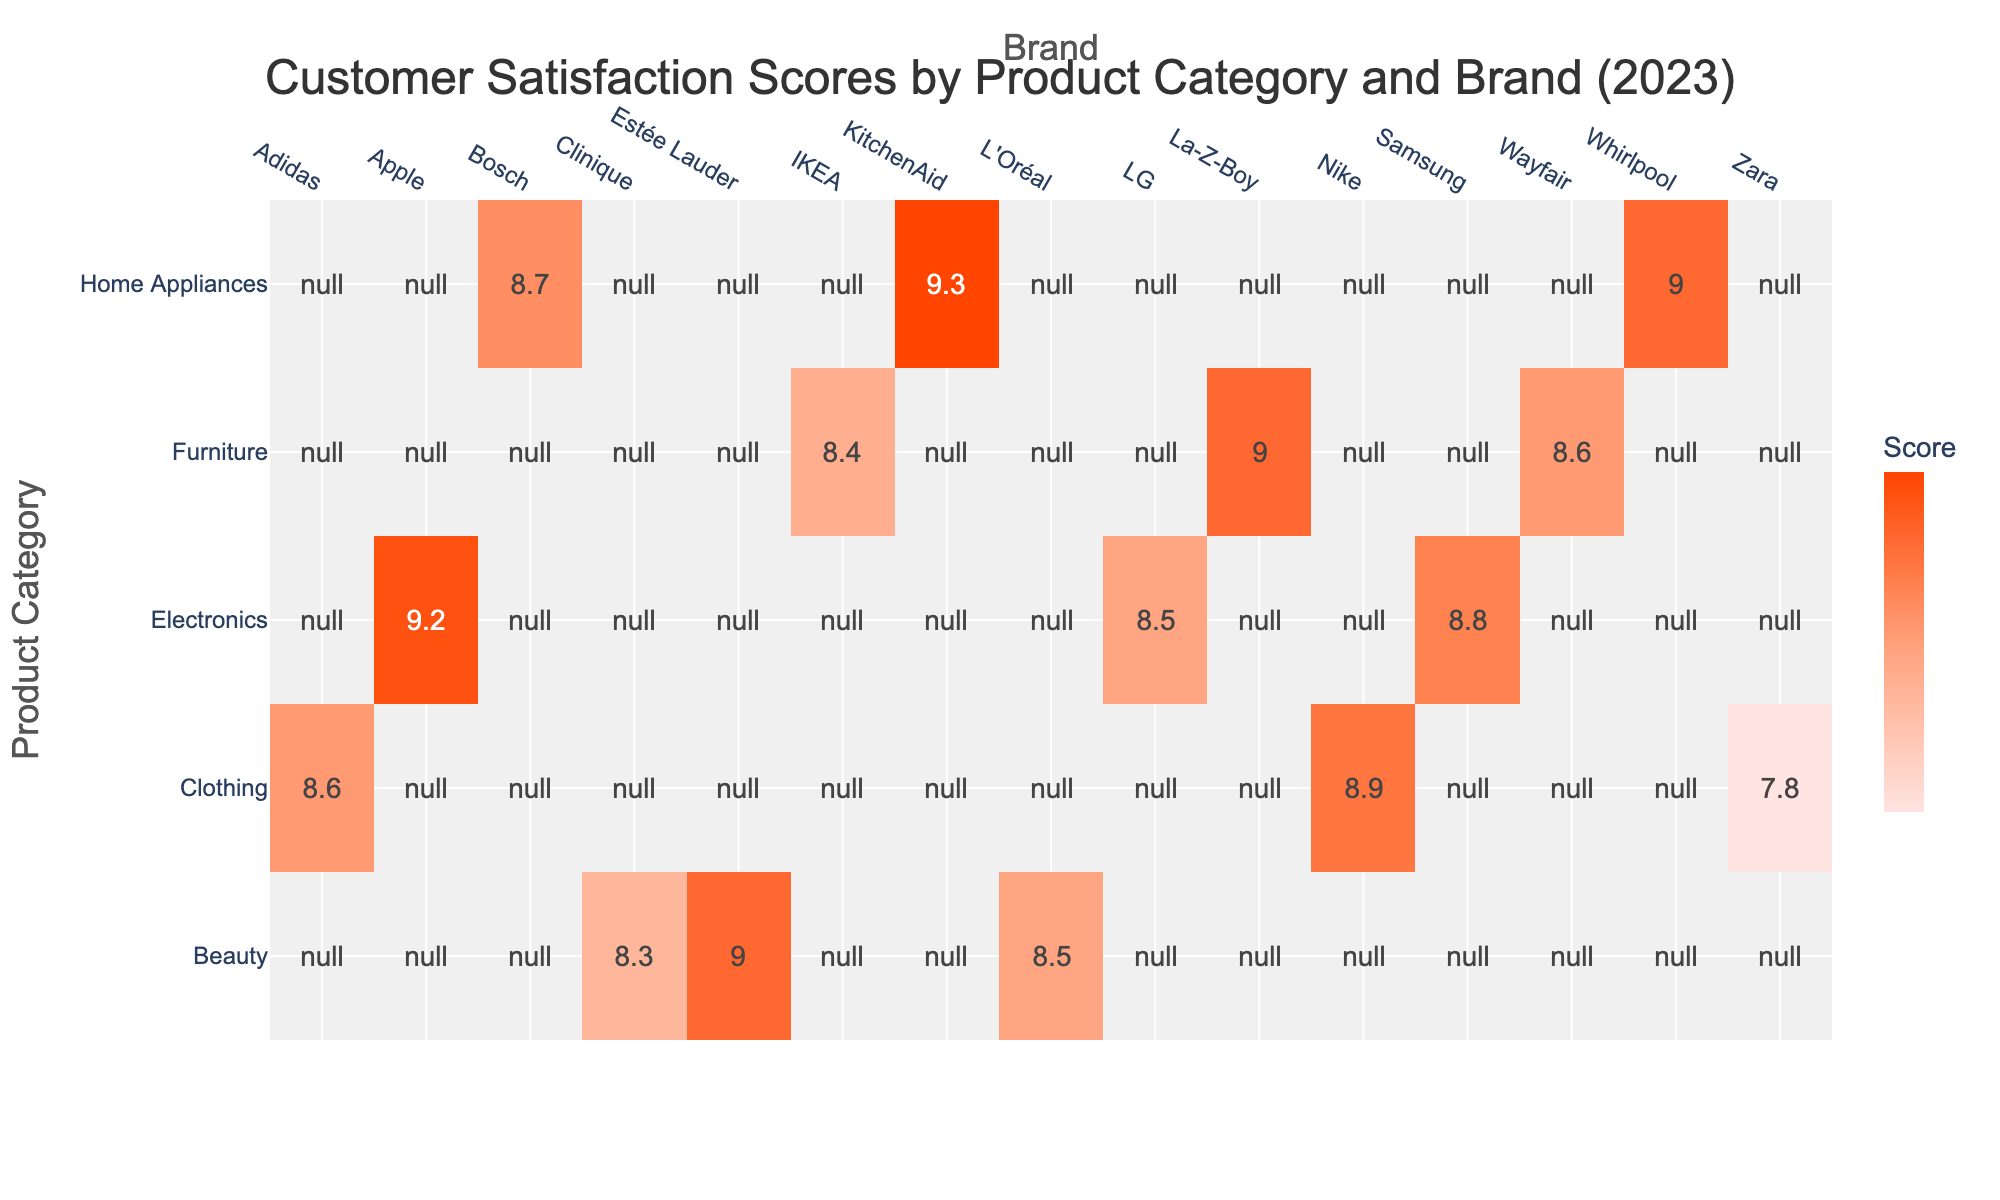What is the Customer Satisfaction Score for KitchenAid? Looking at the table, the score for the KitchenAid brand under the Home Appliances category is directly stated as 9.3.
Answer: 9.3 Which brand in the Electronics category has the lowest Customer Satisfaction Score? Within the Electronics category, we compare the scores: Apple (9.2), Samsung (8.8), and LG (8.5). The lowest score is from LG, which is 8.5.
Answer: LG What is the average Customer Satisfaction Score for the Furniture category? To find the average, we need the scores for IKEA (8.4), La-Z-Boy (9.0), and Wayfair (8.6). The sum is 8.4 + 9.0 + 8.6 = 26. The average then is calculated as 26/3 = 8.67.
Answer: 8.67 Is L'Oréal's Customer Satisfaction Score higher than that of Nike? The score for L'Oréal in the Beauty category is 8.5, while Nike's score in the Clothing category is 8.9. Since 8.5 is less than 8.9, the answer is no.
Answer: No Which product category has the highest Customer Satisfaction Score, and what is that score? We compare the highest scores across categories: Electronics has a maximum of 9.2 (Apple), Home Appliances has 9.3 (KitchenAid), Furniture has 9.0 (La-Z-Boy), Clothing has 8.9 (Nike), and Beauty has 9.0 (Estée Lauder). The highest is from the Home Appliances category with 9.3.
Answer: Home Appliances, 9.3 What is the total number of responses for the brands under the Clothing category? The Clothing category comprises Nike (1400), Adidas (1100), and Zara (650). Adding these gives 1400 + 1100 + 650 = 3150 responses in total.
Answer: 3150 Does the score for Samsung exceed the average of the scores in the Home Appliances category? The Home Appliances scores are Whirlpool (9.0), Bosch (8.7), and KitchenAid (9.3). The average is (9.0 + 8.7 + 9.3) / 3 = 9.0. Samsung’s score is 8.8, which does not exceed 9.0, so the answer is no.
Answer: No What is the difference in Customer Satisfaction Scores between the highest and lowest brands in the Beauty category? In the Beauty category, Estée Lauder has a score of 9.0, while Clinique has 8.3. The difference is 9.0 - 8.3 = 0.7.
Answer: 0.7 